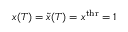<formula> <loc_0><loc_0><loc_500><loc_500>x ( T ) = \tilde { x } ( T ) = x ^ { t h r } = 1</formula> 